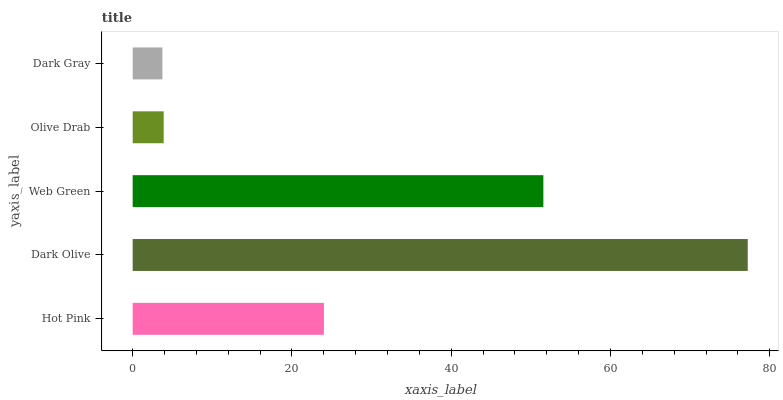Is Dark Gray the minimum?
Answer yes or no. Yes. Is Dark Olive the maximum?
Answer yes or no. Yes. Is Web Green the minimum?
Answer yes or no. No. Is Web Green the maximum?
Answer yes or no. No. Is Dark Olive greater than Web Green?
Answer yes or no. Yes. Is Web Green less than Dark Olive?
Answer yes or no. Yes. Is Web Green greater than Dark Olive?
Answer yes or no. No. Is Dark Olive less than Web Green?
Answer yes or no. No. Is Hot Pink the high median?
Answer yes or no. Yes. Is Hot Pink the low median?
Answer yes or no. Yes. Is Dark Olive the high median?
Answer yes or no. No. Is Olive Drab the low median?
Answer yes or no. No. 